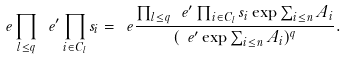<formula> <loc_0><loc_0><loc_500><loc_500>\ e \prod _ { l \leq q } \ e ^ { \prime } \prod _ { i \in C _ { l } } s _ { i } = \ e \frac { \prod _ { l \leq q } \ e ^ { \prime } \prod _ { i \in C _ { l } } s _ { i } \exp \sum _ { i \leq n } A _ { i } } { ( \ e ^ { \prime } \exp \sum _ { i \leq n } A _ { i } ) ^ { q } } .</formula> 